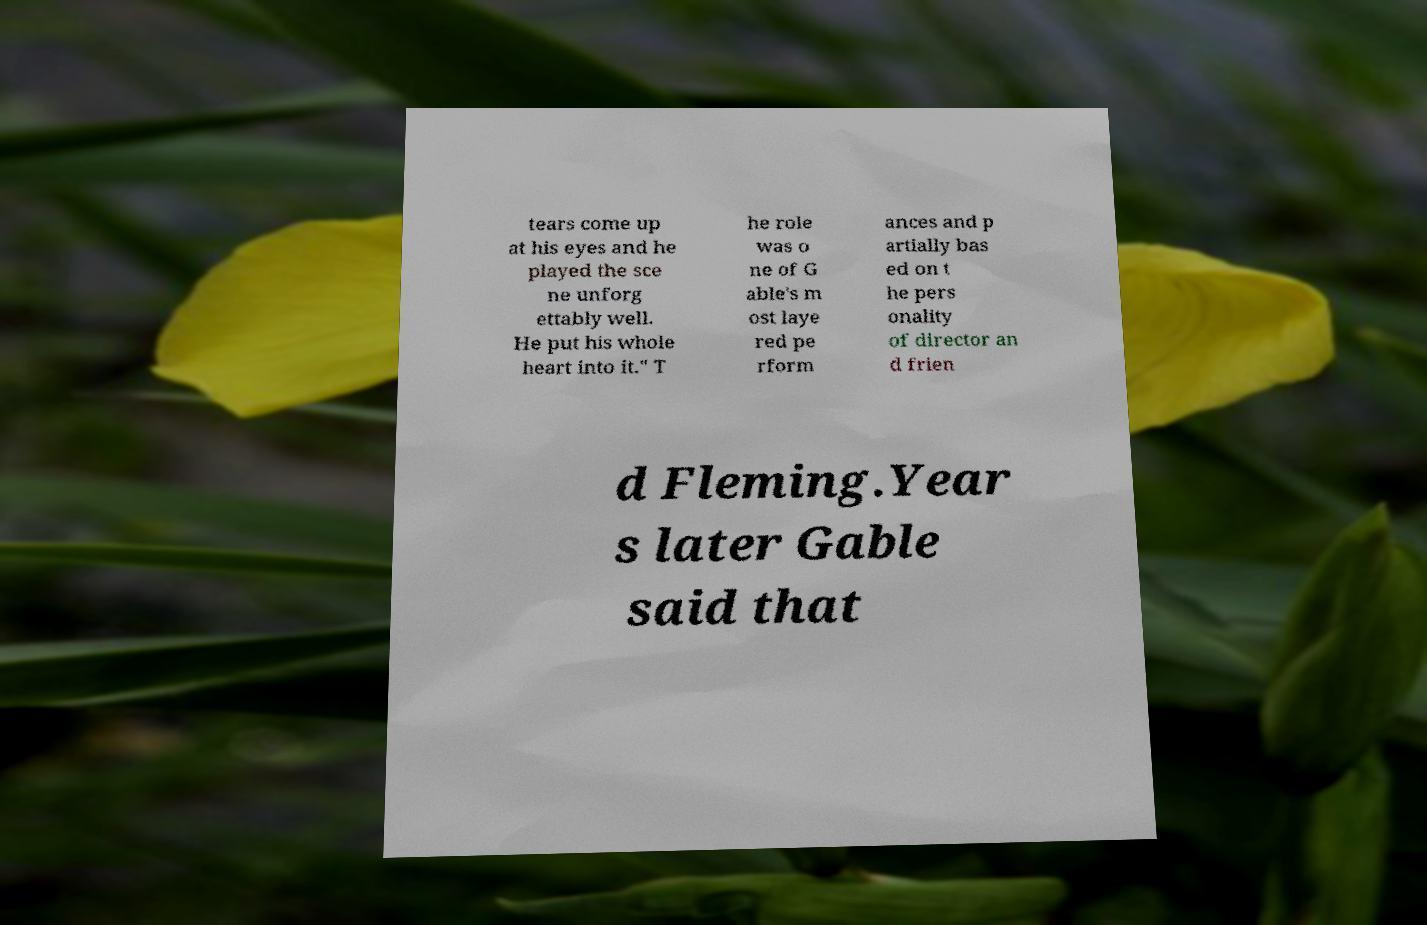There's text embedded in this image that I need extracted. Can you transcribe it verbatim? tears come up at his eyes and he played the sce ne unforg ettably well. He put his whole heart into it." T he role was o ne of G able's m ost laye red pe rform ances and p artially bas ed on t he pers onality of director an d frien d Fleming.Year s later Gable said that 